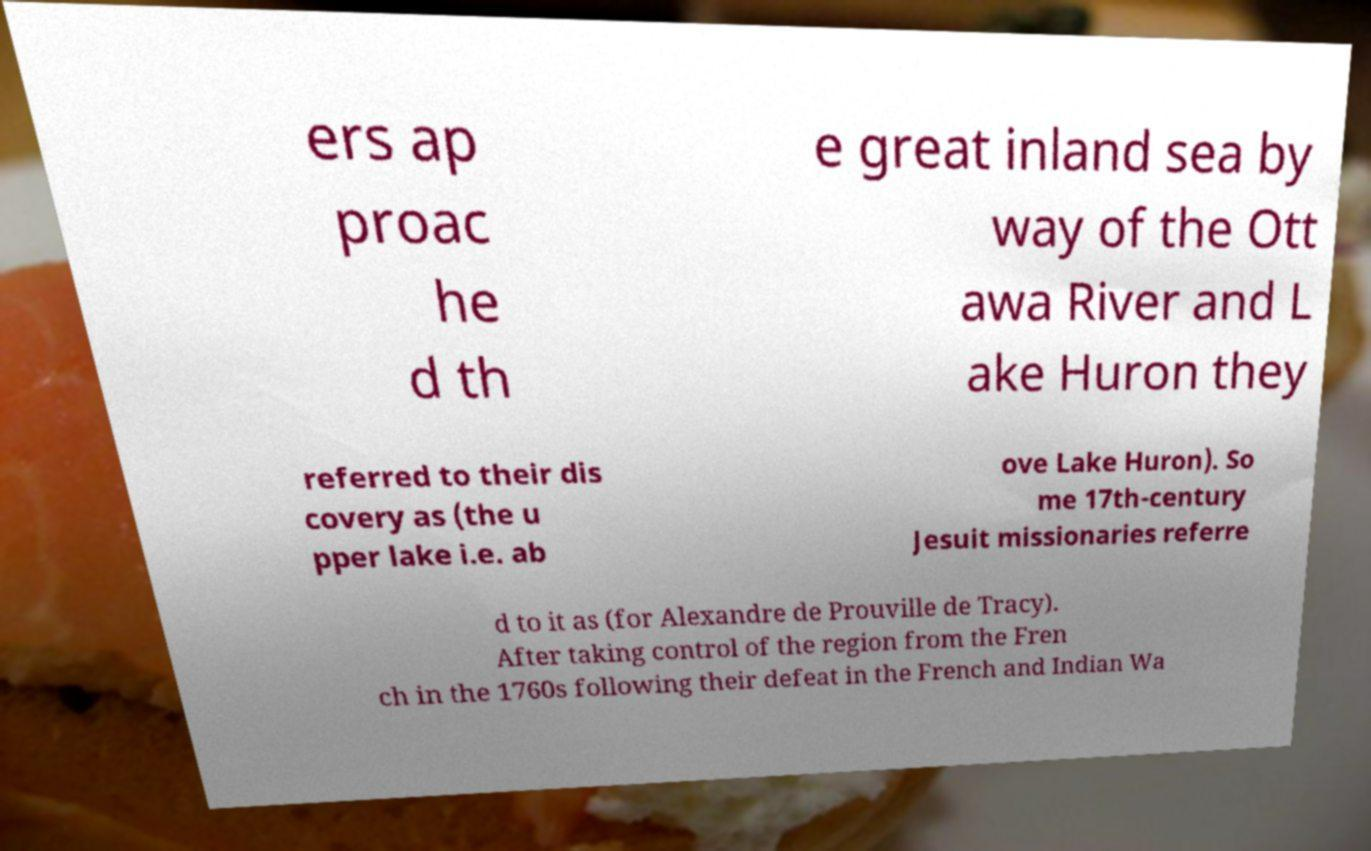Could you assist in decoding the text presented in this image and type it out clearly? ers ap proac he d th e great inland sea by way of the Ott awa River and L ake Huron they referred to their dis covery as (the u pper lake i.e. ab ove Lake Huron). So me 17th-century Jesuit missionaries referre d to it as (for Alexandre de Prouville de Tracy). After taking control of the region from the Fren ch in the 1760s following their defeat in the French and Indian Wa 